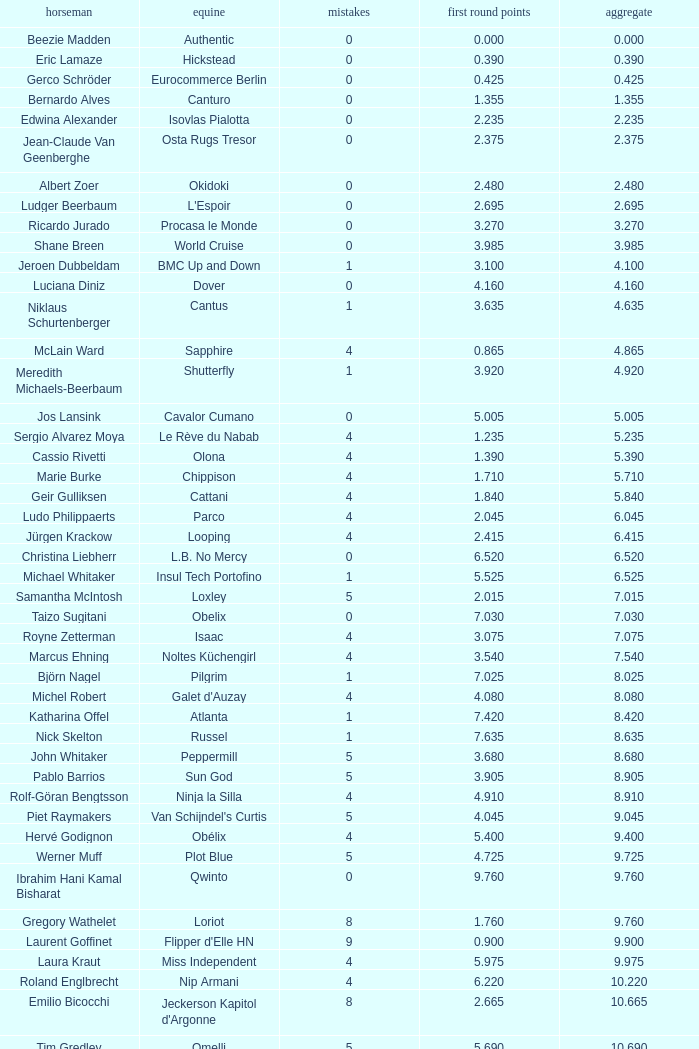Tell me the rider with 18.185 points round 1 Veronika Macanova. Could you parse the entire table? {'header': ['horseman', 'equine', 'mistakes', 'first round points', 'aggregate'], 'rows': [['Beezie Madden', 'Authentic', '0', '0.000', '0.000'], ['Eric Lamaze', 'Hickstead', '0', '0.390', '0.390'], ['Gerco Schröder', 'Eurocommerce Berlin', '0', '0.425', '0.425'], ['Bernardo Alves', 'Canturo', '0', '1.355', '1.355'], ['Edwina Alexander', 'Isovlas Pialotta', '0', '2.235', '2.235'], ['Jean-Claude Van Geenberghe', 'Osta Rugs Tresor', '0', '2.375', '2.375'], ['Albert Zoer', 'Okidoki', '0', '2.480', '2.480'], ['Ludger Beerbaum', "L'Espoir", '0', '2.695', '2.695'], ['Ricardo Jurado', 'Procasa le Monde', '0', '3.270', '3.270'], ['Shane Breen', 'World Cruise', '0', '3.985', '3.985'], ['Jeroen Dubbeldam', 'BMC Up and Down', '1', '3.100', '4.100'], ['Luciana Diniz', 'Dover', '0', '4.160', '4.160'], ['Niklaus Schurtenberger', 'Cantus', '1', '3.635', '4.635'], ['McLain Ward', 'Sapphire', '4', '0.865', '4.865'], ['Meredith Michaels-Beerbaum', 'Shutterfly', '1', '3.920', '4.920'], ['Jos Lansink', 'Cavalor Cumano', '0', '5.005', '5.005'], ['Sergio Alvarez Moya', 'Le Rève du Nabab', '4', '1.235', '5.235'], ['Cassio Rivetti', 'Olona', '4', '1.390', '5.390'], ['Marie Burke', 'Chippison', '4', '1.710', '5.710'], ['Geir Gulliksen', 'Cattani', '4', '1.840', '5.840'], ['Ludo Philippaerts', 'Parco', '4', '2.045', '6.045'], ['Jürgen Krackow', 'Looping', '4', '2.415', '6.415'], ['Christina Liebherr', 'L.B. No Mercy', '0', '6.520', '6.520'], ['Michael Whitaker', 'Insul Tech Portofino', '1', '5.525', '6.525'], ['Samantha McIntosh', 'Loxley', '5', '2.015', '7.015'], ['Taizo Sugitani', 'Obelix', '0', '7.030', '7.030'], ['Royne Zetterman', 'Isaac', '4', '3.075', '7.075'], ['Marcus Ehning', 'Noltes Küchengirl', '4', '3.540', '7.540'], ['Björn Nagel', 'Pilgrim', '1', '7.025', '8.025'], ['Michel Robert', "Galet d'Auzay", '4', '4.080', '8.080'], ['Katharina Offel', 'Atlanta', '1', '7.420', '8.420'], ['Nick Skelton', 'Russel', '1', '7.635', '8.635'], ['John Whitaker', 'Peppermill', '5', '3.680', '8.680'], ['Pablo Barrios', 'Sun God', '5', '3.905', '8.905'], ['Rolf-Göran Bengtsson', 'Ninja la Silla', '4', '4.910', '8.910'], ['Piet Raymakers', "Van Schijndel's Curtis", '5', '4.045', '9.045'], ['Hervé Godignon', 'Obélix', '4', '5.400', '9.400'], ['Werner Muff', 'Plot Blue', '5', '4.725', '9.725'], ['Ibrahim Hani Kamal Bisharat', 'Qwinto', '0', '9.760', '9.760'], ['Gregory Wathelet', 'Loriot', '8', '1.760', '9.760'], ['Laurent Goffinet', "Flipper d'Elle HN", '9', '0.900', '9.900'], ['Laura Kraut', 'Miss Independent', '4', '5.975', '9.975'], ['Roland Englbrecht', 'Nip Armani', '4', '6.220', '10.220'], ['Emilio Bicocchi', "Jeckerson Kapitol d'Argonne", '8', '2.665', '10.665'], ['Tim Gredley', 'Omelli', '5', '5.690', '10.690'], ['Beat Mändli', 'Indigo IX', '4', '6.780', '10.780'], ['Christian Ahlmann', 'Cöster', '8', '4.000', '12.000'], ['Tina Lund', 'Carola', '9', '3.610', '12.610'], ['Max Amaya', 'Church Road', '8', '4.790', '12.790'], ['Álvaro Alfonso de Miranda Neto', 'Nike', '9', '4.235', '13.235'], ['Jesus Garmendia Echeverria', 'Maddock', '8', '5.335', '13.335'], ['Carlos Lopez', 'Instit', '10', '3.620', '13.620'], ['Juan Carlos García', 'Loro Piana Albin III', '5', '9.020', '14.020'], ['Cameron Hanley', 'Siec Hippica Kerman', '9', '5.375', '14.375'], ['Ricardo Kierkegaard', 'Rey Z', '8', '6.805', '14.805'], ['Jill Henselwood', 'Special Ed', '9', '6.165', '15.165'], ['Margie Engle', "Hidden Creek's Quervo Gold", '4', '12.065', '16.065'], ['Judy-Ann Melchoir', 'Grande Dame Z', '9', '7.310', '16.310'], ['Maria Gretzer', 'Spender S', '9', '7.385', '16.385'], ['Billy Twomey', 'Luidam', '9', '7.615', '16.615'], ['Federico Fernandez', 'Bohemio', '8', '9.610', '17.610'], ['Jonella Ligresti', 'Quinta 27', '6', '12.365', '18.365'], ['Ian Millar', 'In Style', '9', '9.370', '18.370'], ['Mikael Forsten', "BMC's Skybreaker", '12', '6.435', '18.435'], ['Sebastian Numminen', 'Sails Away', '13', '5.455', '18.455'], ['Stefan Eder', 'Cartier PSG', '12', '6.535', '18.535'], ['Dirk Demeersman', 'Clinton', '16', '2.755', '18.755'], ['Antonis Petris', 'Gredo la Daviere', '13', '6.300', '19.300'], ['Gunnar Klettenberg', 'Novesta', '9', '10.620', '19.620'], ['Syed Omar Almohdzar', 'Lui', '10', '9.820', '19.820'], ['Tony Andre Hansen', 'Camiro', '13', '7.245', '20.245'], ['Manuel Fernandez Saro', 'Quin Chin', '13', '7.465', '20.465'], ['James Wingrave', 'Agropoint Calira', '14', '6.855', '20.855'], ['Rod Brown', 'Mr. Burns', '9', '12.300', '21.300'], ['Jiri Papousek', 'La Manche T', '13', '8.440', '21.440'], ['Marcela Lobo', 'Joskin', '14', '7.600', '21.600'], ['Yuko Itakura', 'Portvliet', '9', '12.655', '21.655'], ['Zsolt Pirik', 'Havanna', '9', '13.050', '22.050'], ['Fabrice Lyon', 'Jasmine du Perron', '11', '12.760', '23.760'], ['Florian Angot', 'First de Launay', '16', '8.055', '24.055'], ['Peter McMahon', 'Kolora Stud Genoa', '9', '15.195', '24.195'], ['Giuseppe Rolli', 'Jericho de la Vie', '17', '7.910', '24.910'], ['Alberto Michan', 'Chinobampo Lavita', '13', '12.330', '25.330'], ['Hanno Ellermann', 'Poncorde', '17', '8.600', '25.600'], ['Antonio Portela Carneiro', 'Echo de Lessay', '18', '8.565', '26.565'], ['Gerfried Puck', '11th Bleeker', '21', '6.405', '27.405'], ['H.H. Prince Faisal Al-Shalan', 'Uthago', '18', '10.205', '28.205'], ['Vladimir Beletskiy', 'Rezonanz', '21', '7.725', '28.725'], ['Noora Pentti', 'Evli Cagliostro', '17', '12.455', '29.455'], ['Mohammed Al-Kumaiti', 'Al-Mutawakel', '17', '12.490', '29.490'], ['Guillermo Obligado', 'Carlson', '18', '11.545', '29.545'], ['Kamal Bahamdan', 'Campus', '17', '13.190', '30.190'], ['Veronika Macanova', 'Pompos', '13', '18.185', '31.185'], ['Vladimir Panchenko', 'Lanteno', '17', '14.460', '31.460'], ['Jose Larocca', 'Svante', '25', '8.190', '33.190'], ['Abdullah Al-Sharbatly', 'Hugo Gesmeray', '25', '8.585', '33.585'], ['Eiken Sato', 'Cayak DH', '17', '17.960', '34.960'], ['Gennadiy Gashiboyazov', 'Papirus', '28', '8.685', '36.685'], ['Karim El-Zoghby', 'Baragway', '21', '16.360', '37.360'], ['Ondrej Nagr', 'Atlas', '19', '19.865', '38.865'], ['Roger Hessen', 'Quito', '23', '17.410', '40.410'], ['Zdenek Zila', 'Pinot Grigio', '15', '26.035', '41.035'], ['Rene Lopez', 'Isky', '30', '11.675', '41.675'], ['Emmanouela Athanassiades', 'Rimini Z', '18', '24.380', '42.380'], ['Jamie Kermond', 'Stylish King', '21', '46.035', '67.035'], ['Malin Baryard-Johnsson', 'Butterfly Flip', '29', '46.035', '75.035'], ['Manuel Torres', 'Chambacunero', 'Fall', 'Fall', '5.470'], ['Krzyszlof Ludwiczak', 'HOF Schretstakens Quamiro', 'Eliminated', 'Eliminated', '7.460'], ['Grant Wilson', 'Up and Down Cellebroedersbos', 'Refusal', 'Refusal', '14.835'], ['Chris Pratt', 'Rivendell', 'Fall', 'Fall', '15.220'], ['Ariana Azcarraga', 'Sambo', 'Eliminated', 'Eliminated', '15.945'], ['Jose Alfredo Hernandez Ortega', 'Semtex P', 'Eliminated', 'Eliminated', '46.035'], ['H.R.H. Prince Abdullah Al-Soud', 'Allah Jabek', 'Retired', 'Retired', '46.035']]} 